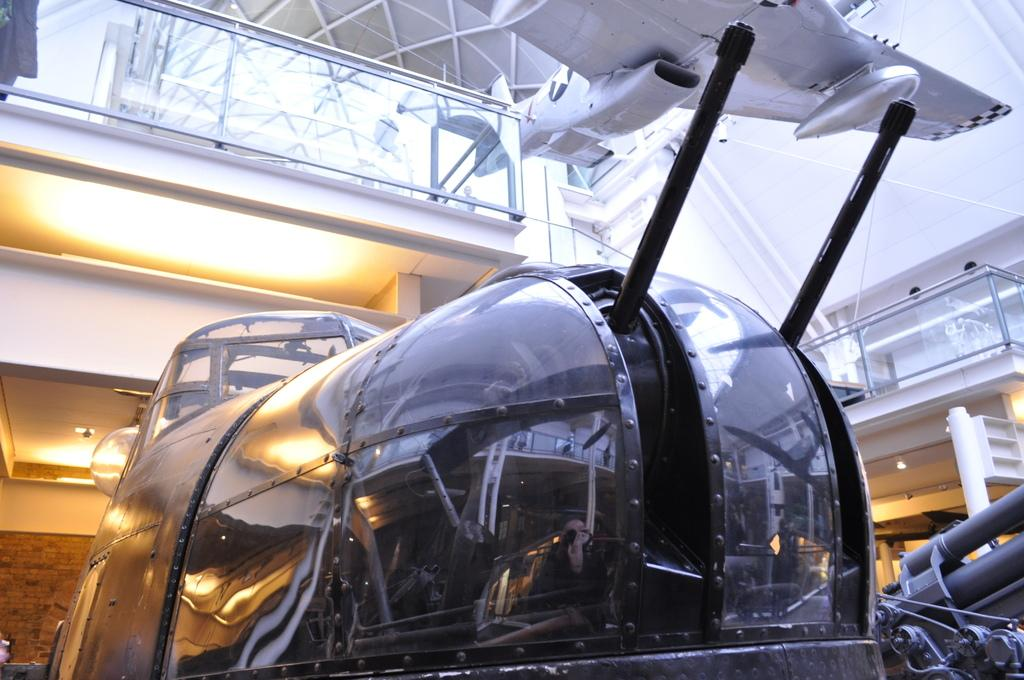What type of location is depicted in the image? The image shows an inner view of a building. What vehicles can be seen inside the building? There is an aircraft and a helicopter in the image. Where is the bed located in the image? There is no bed present in the image. Can you see any windows in the image? The provided facts do not mention any windows in the image. Is there a book visible in the image? There is no book present in the image. 